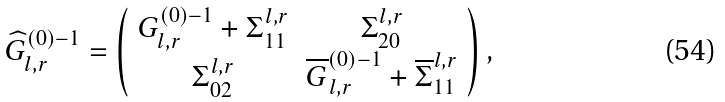Convert formula to latex. <formula><loc_0><loc_0><loc_500><loc_500>\widehat { G } _ { l , r } ^ { \left ( 0 \right ) - 1 } = \left ( \begin{array} { c c } G _ { l , r } ^ { \left ( 0 \right ) - 1 } + \Sigma _ { 1 1 } ^ { l , r } & \Sigma _ { 2 0 } ^ { l , r } \\ \Sigma _ { 0 2 } ^ { l , r } & \overline { G } _ { l , r } ^ { \left ( 0 \right ) - 1 } + \overline { \Sigma } _ { 1 1 } ^ { l , r } \end{array} \right ) ,</formula> 